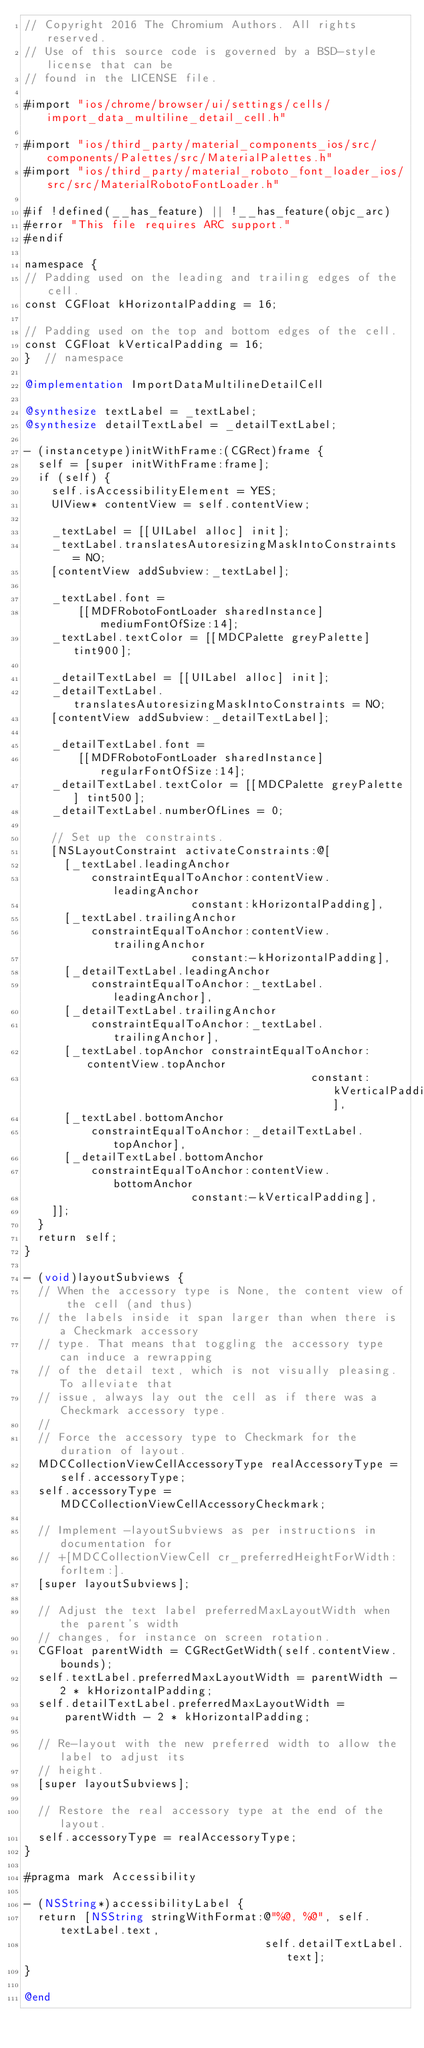Convert code to text. <code><loc_0><loc_0><loc_500><loc_500><_ObjectiveC_>// Copyright 2016 The Chromium Authors. All rights reserved.
// Use of this source code is governed by a BSD-style license that can be
// found in the LICENSE file.

#import "ios/chrome/browser/ui/settings/cells/import_data_multiline_detail_cell.h"

#import "ios/third_party/material_components_ios/src/components/Palettes/src/MaterialPalettes.h"
#import "ios/third_party/material_roboto_font_loader_ios/src/src/MaterialRobotoFontLoader.h"

#if !defined(__has_feature) || !__has_feature(objc_arc)
#error "This file requires ARC support."
#endif

namespace {
// Padding used on the leading and trailing edges of the cell.
const CGFloat kHorizontalPadding = 16;

// Padding used on the top and bottom edges of the cell.
const CGFloat kVerticalPadding = 16;
}  // namespace

@implementation ImportDataMultilineDetailCell

@synthesize textLabel = _textLabel;
@synthesize detailTextLabel = _detailTextLabel;

- (instancetype)initWithFrame:(CGRect)frame {
  self = [super initWithFrame:frame];
  if (self) {
    self.isAccessibilityElement = YES;
    UIView* contentView = self.contentView;

    _textLabel = [[UILabel alloc] init];
    _textLabel.translatesAutoresizingMaskIntoConstraints = NO;
    [contentView addSubview:_textLabel];

    _textLabel.font =
        [[MDFRobotoFontLoader sharedInstance] mediumFontOfSize:14];
    _textLabel.textColor = [[MDCPalette greyPalette] tint900];

    _detailTextLabel = [[UILabel alloc] init];
    _detailTextLabel.translatesAutoresizingMaskIntoConstraints = NO;
    [contentView addSubview:_detailTextLabel];

    _detailTextLabel.font =
        [[MDFRobotoFontLoader sharedInstance] regularFontOfSize:14];
    _detailTextLabel.textColor = [[MDCPalette greyPalette] tint500];
    _detailTextLabel.numberOfLines = 0;

    // Set up the constraints.
    [NSLayoutConstraint activateConstraints:@[
      [_textLabel.leadingAnchor
          constraintEqualToAnchor:contentView.leadingAnchor
                         constant:kHorizontalPadding],
      [_textLabel.trailingAnchor
          constraintEqualToAnchor:contentView.trailingAnchor
                         constant:-kHorizontalPadding],
      [_detailTextLabel.leadingAnchor
          constraintEqualToAnchor:_textLabel.leadingAnchor],
      [_detailTextLabel.trailingAnchor
          constraintEqualToAnchor:_textLabel.trailingAnchor],
      [_textLabel.topAnchor constraintEqualToAnchor:contentView.topAnchor
                                           constant:kVerticalPadding],
      [_textLabel.bottomAnchor
          constraintEqualToAnchor:_detailTextLabel.topAnchor],
      [_detailTextLabel.bottomAnchor
          constraintEqualToAnchor:contentView.bottomAnchor
                         constant:-kVerticalPadding],
    ]];
  }
  return self;
}

- (void)layoutSubviews {
  // When the accessory type is None, the content view of the cell (and thus)
  // the labels inside it span larger than when there is a Checkmark accessory
  // type. That means that toggling the accessory type can induce a rewrapping
  // of the detail text, which is not visually pleasing. To alleviate that
  // issue, always lay out the cell as if there was a Checkmark accessory type.
  //
  // Force the accessory type to Checkmark for the duration of layout.
  MDCCollectionViewCellAccessoryType realAccessoryType = self.accessoryType;
  self.accessoryType = MDCCollectionViewCellAccessoryCheckmark;

  // Implement -layoutSubviews as per instructions in documentation for
  // +[MDCCollectionViewCell cr_preferredHeightForWidth:forItem:].
  [super layoutSubviews];

  // Adjust the text label preferredMaxLayoutWidth when the parent's width
  // changes, for instance on screen rotation.
  CGFloat parentWidth = CGRectGetWidth(self.contentView.bounds);
  self.textLabel.preferredMaxLayoutWidth = parentWidth - 2 * kHorizontalPadding;
  self.detailTextLabel.preferredMaxLayoutWidth =
      parentWidth - 2 * kHorizontalPadding;

  // Re-layout with the new preferred width to allow the label to adjust its
  // height.
  [super layoutSubviews];

  // Restore the real accessory type at the end of the layout.
  self.accessoryType = realAccessoryType;
}

#pragma mark Accessibility

- (NSString*)accessibilityLabel {
  return [NSString stringWithFormat:@"%@, %@", self.textLabel.text,
                                    self.detailTextLabel.text];
}

@end
</code> 